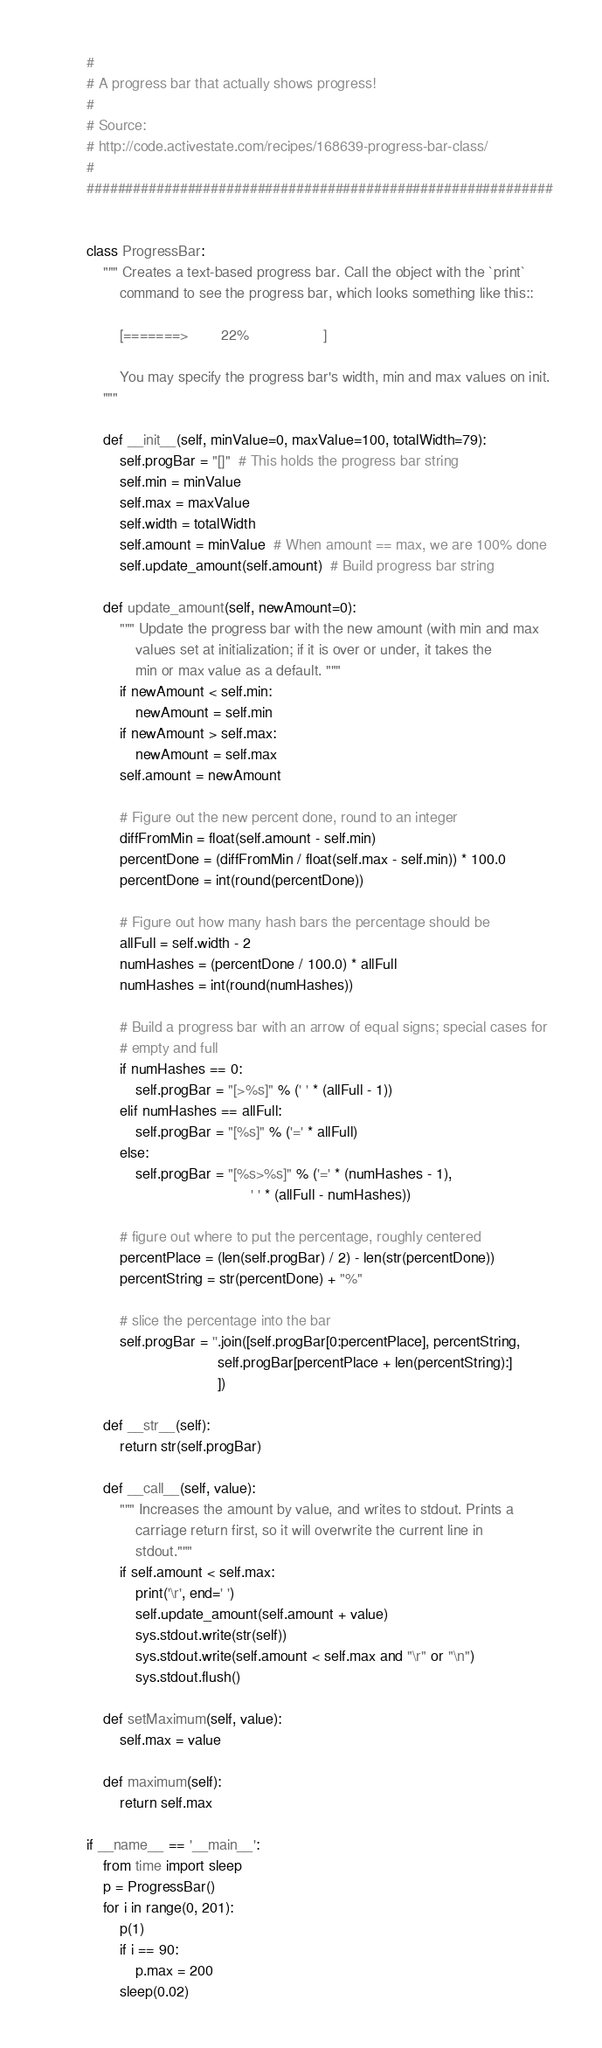Convert code to text. <code><loc_0><loc_0><loc_500><loc_500><_Python_>#
# A progress bar that actually shows progress!
#
# Source:
# http://code.activestate.com/recipes/168639-progress-bar-class/
#
############################################################


class ProgressBar:
    """ Creates a text-based progress bar. Call the object with the `print`
        command to see the progress bar, which looks something like this::

        [=======>        22%                  ]

        You may specify the progress bar's width, min and max values on init.
    """

    def __init__(self, minValue=0, maxValue=100, totalWidth=79):
        self.progBar = "[]"  # This holds the progress bar string
        self.min = minValue
        self.max = maxValue
        self.width = totalWidth
        self.amount = minValue  # When amount == max, we are 100% done
        self.update_amount(self.amount)  # Build progress bar string

    def update_amount(self, newAmount=0):
        """ Update the progress bar with the new amount (with min and max
            values set at initialization; if it is over or under, it takes the
            min or max value as a default. """
        if newAmount < self.min:
            newAmount = self.min
        if newAmount > self.max:
            newAmount = self.max
        self.amount = newAmount

        # Figure out the new percent done, round to an integer
        diffFromMin = float(self.amount - self.min)
        percentDone = (diffFromMin / float(self.max - self.min)) * 100.0
        percentDone = int(round(percentDone))

        # Figure out how many hash bars the percentage should be
        allFull = self.width - 2
        numHashes = (percentDone / 100.0) * allFull
        numHashes = int(round(numHashes))

        # Build a progress bar with an arrow of equal signs; special cases for
        # empty and full
        if numHashes == 0:
            self.progBar = "[>%s]" % (' ' * (allFull - 1))
        elif numHashes == allFull:
            self.progBar = "[%s]" % ('=' * allFull)
        else:
            self.progBar = "[%s>%s]" % ('=' * (numHashes - 1),
                                        ' ' * (allFull - numHashes))

        # figure out where to put the percentage, roughly centered
        percentPlace = (len(self.progBar) / 2) - len(str(percentDone))
        percentString = str(percentDone) + "%"

        # slice the percentage into the bar
        self.progBar = ''.join([self.progBar[0:percentPlace], percentString,
                                self.progBar[percentPlace + len(percentString):]
                                ])

    def __str__(self):
        return str(self.progBar)

    def __call__(self, value):
        """ Increases the amount by value, and writes to stdout. Prints a
            carriage return first, so it will overwrite the current line in
            stdout."""
        if self.amount < self.max:
            print('\r', end=' ')
            self.update_amount(self.amount + value)
            sys.stdout.write(str(self))
            sys.stdout.write(self.amount < self.max and "\r" or "\n")
            sys.stdout.flush()

    def setMaximum(self, value):
        self.max = value

    def maximum(self):
        return self.max

if __name__ == '__main__':
    from time import sleep
    p = ProgressBar()
    for i in range(0, 201):
        p(1)
        if i == 90:
            p.max = 200
        sleep(0.02)
</code> 